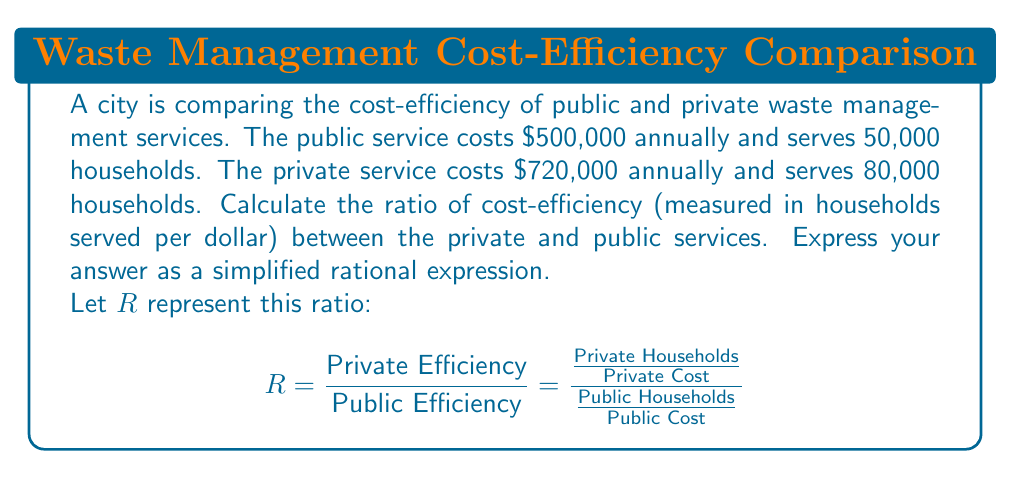Could you help me with this problem? To solve this problem, we'll follow these steps:

1) Calculate the efficiency of the public service:
   $$\text{Public Efficiency} = \frac{50,000}{500,000} = \frac{1}{10} \text{ households/dollar}$$

2) Calculate the efficiency of the private service:
   $$\text{Private Efficiency} = \frac{80,000}{720,000} = \frac{1}{9} \text{ households/dollar}$$

3) Set up the ratio $R$:
   $$R = \frac{\frac{1}{9}}{\frac{1}{10}}$$

4) To divide fractions, we multiply by the reciprocal:
   $$R = \frac{1}{9} \times \frac{10}{1} = \frac{10}{9}$$

5) This fraction is already in its simplest form, so our final answer is $\frac{10}{9}$.

Interpretation: The private service is $\frac{10}{9}$ or approximately $1.11$ times as efficient as the public service in terms of households served per dollar spent.
Answer: $\frac{10}{9}$ 